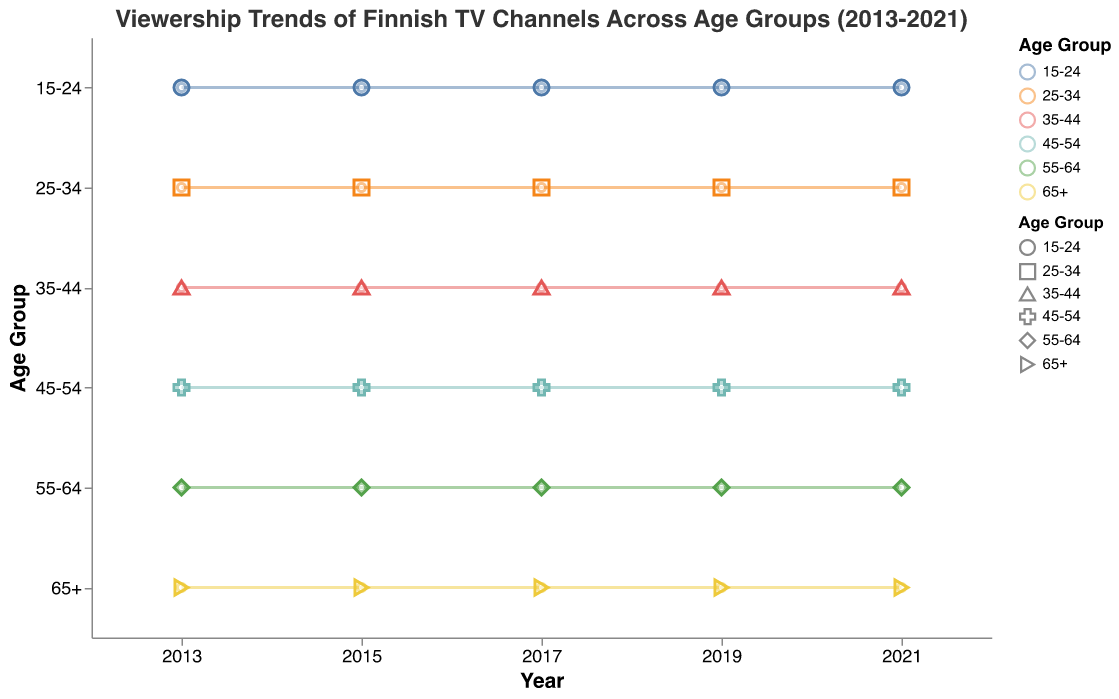What is the most popular TV channel among the 15-24 age group in 2021? Look at the data points for the year 2021 for the 15-24 age group and identify the channel with the highest value. Nelonen has a viewership of 30, which is the highest.
Answer: Nelonen Which age group had the highest viewership for YLE TV1 in 2017? Look at the data points for the year 2017, checking the viewership values for YLE TV1 across all age groups. The 65+ age group had a viewership of 42, which is the highest.
Answer: 65+ How did the viewership for MTV3 change for the 25-34 age group from 2013 to 2021? Compare the viewership values for MTV3 in 2013 (35) and 2021 (28) for the 25-34 age group. The change in viewership is 35 - 28 = 7.
Answer: Decreased by 7 Which channel had the most consistent viewership trend for the 35-44 age group between 2013 and 2021? Examine the viewership trends for each channel in the 35-44 age group and look at the variability in values. YLE TV1 consistently decreased but with a smaller range compared to others, from 30 to 25.
Answer: YLE TV1 Which age group shows the most decline in viewership for YLE TV2 from 2013 to 2021? Compare the difference in viewership for YLE TV2 from 2013 to 2021 across age groups. The 15-24 age group shows the most decline with a drop from 15 to 10.
Answer: 15-24 What is the average viewership for Sub in 2019 across all age groups? Sum up the viewership values for Sub in 2019 (17 + 22 + 27 + 32 + 37 + 42) and divide by the number of age groups (6). (17 + 22 + 27 + 32 + 37 + 42) / 6 = 29.5
Answer: 29.5 Which channel had the highest increase in viewership for the 55-64 age group from 2013 to 2021? Compare the viewership values from 2013 to 2021 for the 55-64 age group. Nelonen increased from 45 in 2013 to 50 in 2021, showing the highest increase of 5.
Answer: Nelonen What pattern can be observed in the viewership trends of Jim across different age groups? Look at the trends for Jim across all age groups from 2013 to 2021. Jim's viewership tends to increase slightly across all age groups over the years, with older age groups showing more gradual increases.
Answer: Slight increase across all age groups Which age group had the highest combined viewership for YLE TV1 and YLE TV2 in 2015? Sum the viewership for YLE TV1 and YLE TV2 in 2015 across all age groups. 45-54 (33 + 28 = 61) has the highest combined viewership.
Answer: 45-54 